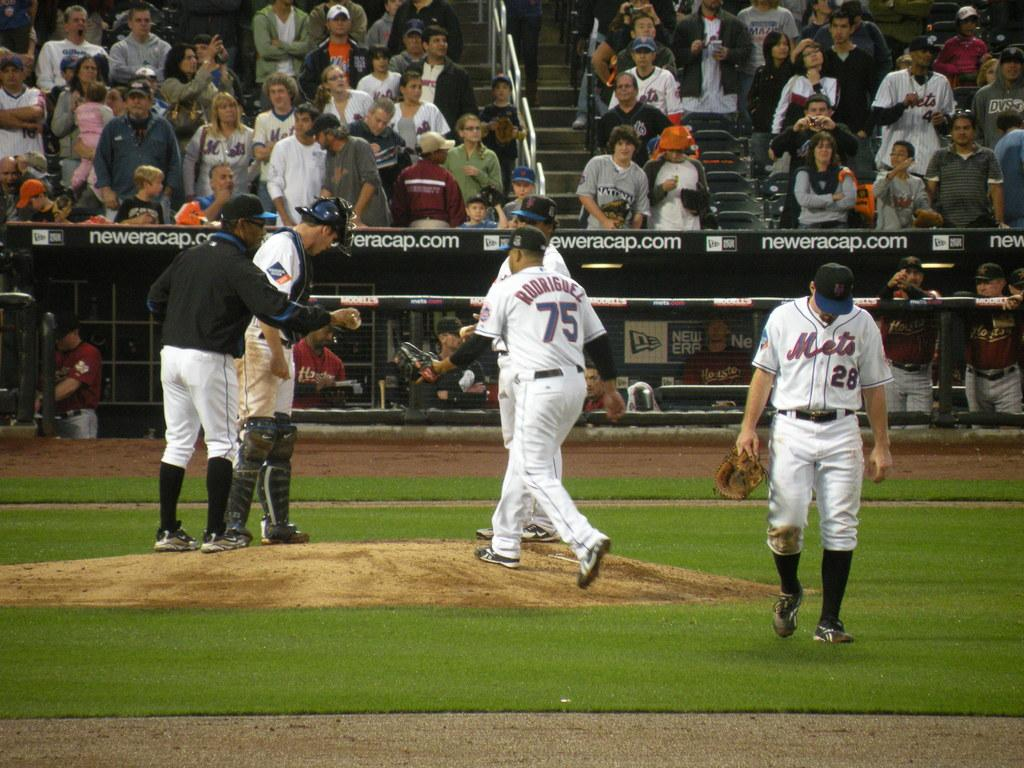<image>
Give a short and clear explanation of the subsequent image. Player number 75 for the Mets comes to the mound during a pitching change. 